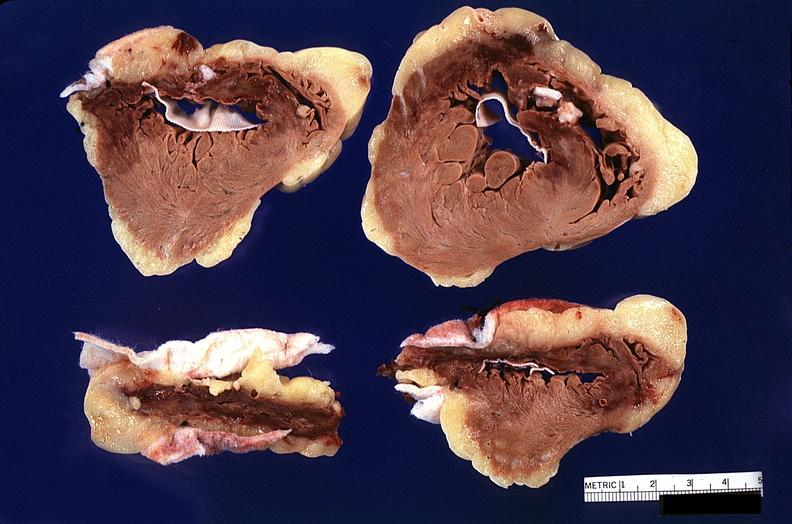what does this image show?
Answer the question using a single word or phrase. Heart 